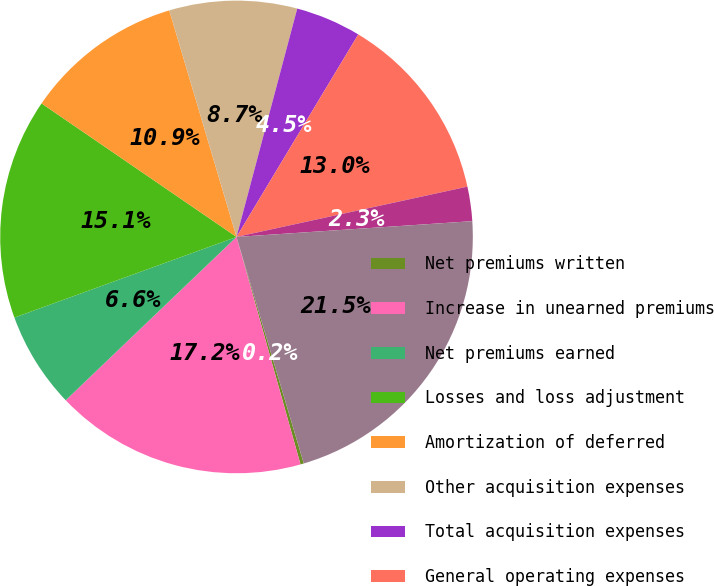Convert chart to OTSL. <chart><loc_0><loc_0><loc_500><loc_500><pie_chart><fcel>Net premiums written<fcel>Increase in unearned premiums<fcel>Net premiums earned<fcel>Losses and loss adjustment<fcel>Amortization of deferred<fcel>Other acquisition expenses<fcel>Total acquisition expenses<fcel>General operating expenses<fcel>Net investment income<fcel>Pre-tax operating income<nl><fcel>0.23%<fcel>17.22%<fcel>6.6%<fcel>15.1%<fcel>10.85%<fcel>8.73%<fcel>4.48%<fcel>12.97%<fcel>2.35%<fcel>21.47%<nl></chart> 